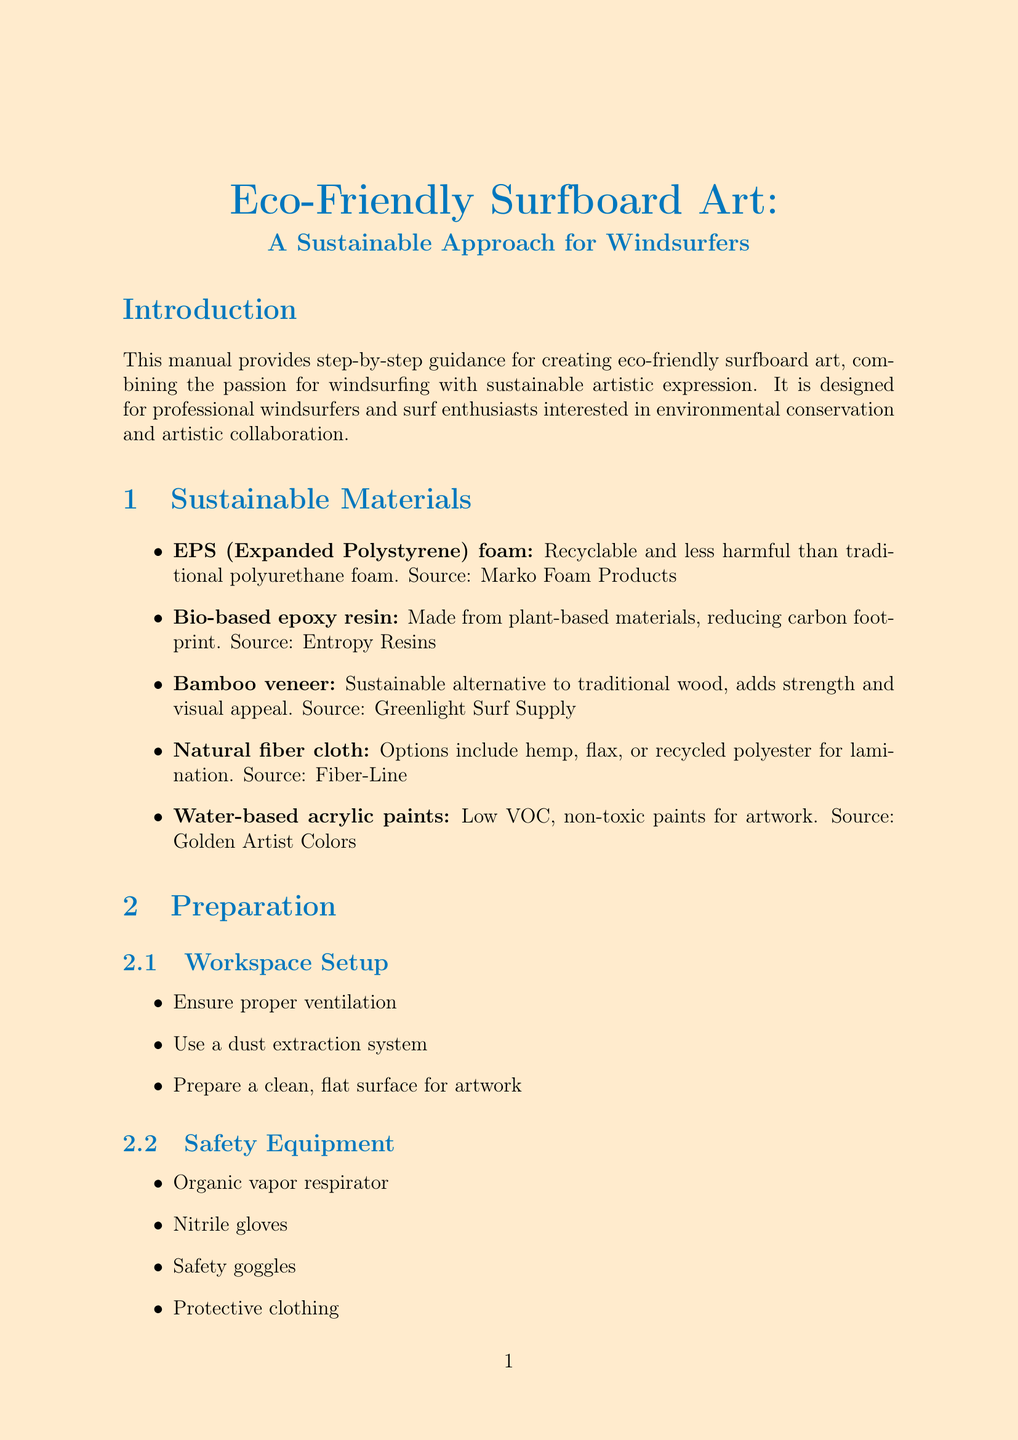What is the title of the manual? The title of the manual is stated at the beginning, which is "Eco-Friendly Surfboard Art: A Sustainable Approach for Windsurfers."
Answer: Eco-Friendly Surfboard Art: A Sustainable Approach for Windsurfers Who is the intended audience for the manual? The manual specifies the audience in the introduction, stating it is for professional windsurfers and surf enthusiasts.
Answer: Professional windsurfers and surf enthusiasts What material is recommended for a sustainable base layer? The document mentions a specific material for the base layer application in the sustainable materials section.
Answer: Bio-based epoxy resin In which step do you apply a protective coating? The step about applying a protective coating is listed within the step-by-step process section, indicating its order.
Answer: Step 6 What eco-friendly technique involves using old wetsuit pieces? The eco-friendly technique section provides various techniques, including one that mentions the use of old wetsuit pieces.
Answer: Upcycling Which source supplies bamboo veneer? The sustainable materials section lists sources for each material, specifically for bamboo veneer.
Answer: Greenlight Surf Supply Name one of the suggested collaboration partners. The collaboration ideas section lists potential partners for projects, one of which can be identified.
Answer: Marine biologists What is one maintenance tip provided in the document? The maintenance and care section suggests several practices to maintain the artwork, one of which can be selected.
Answer: Store artwork-adorned boards in a cool, dry place away from direct sunlight 